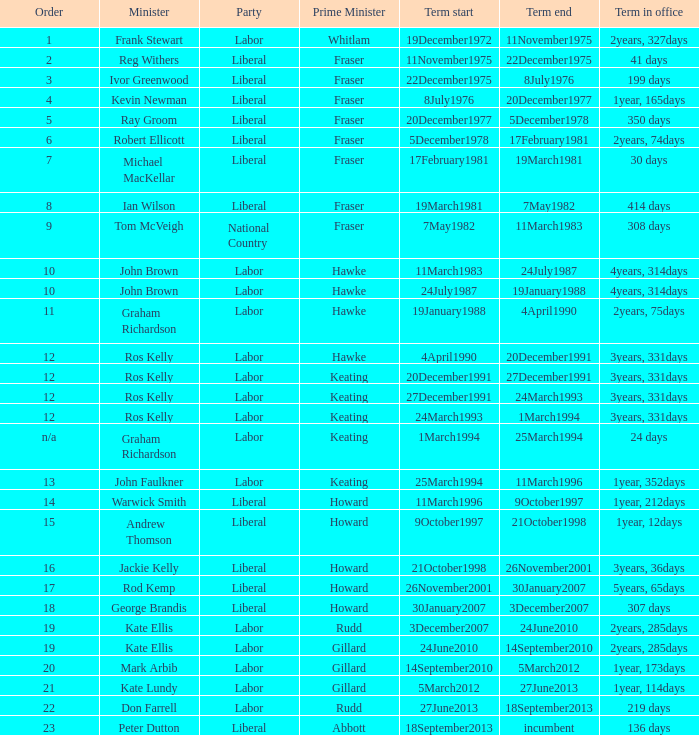What is the office term with a ranking of 9? 308 days. 